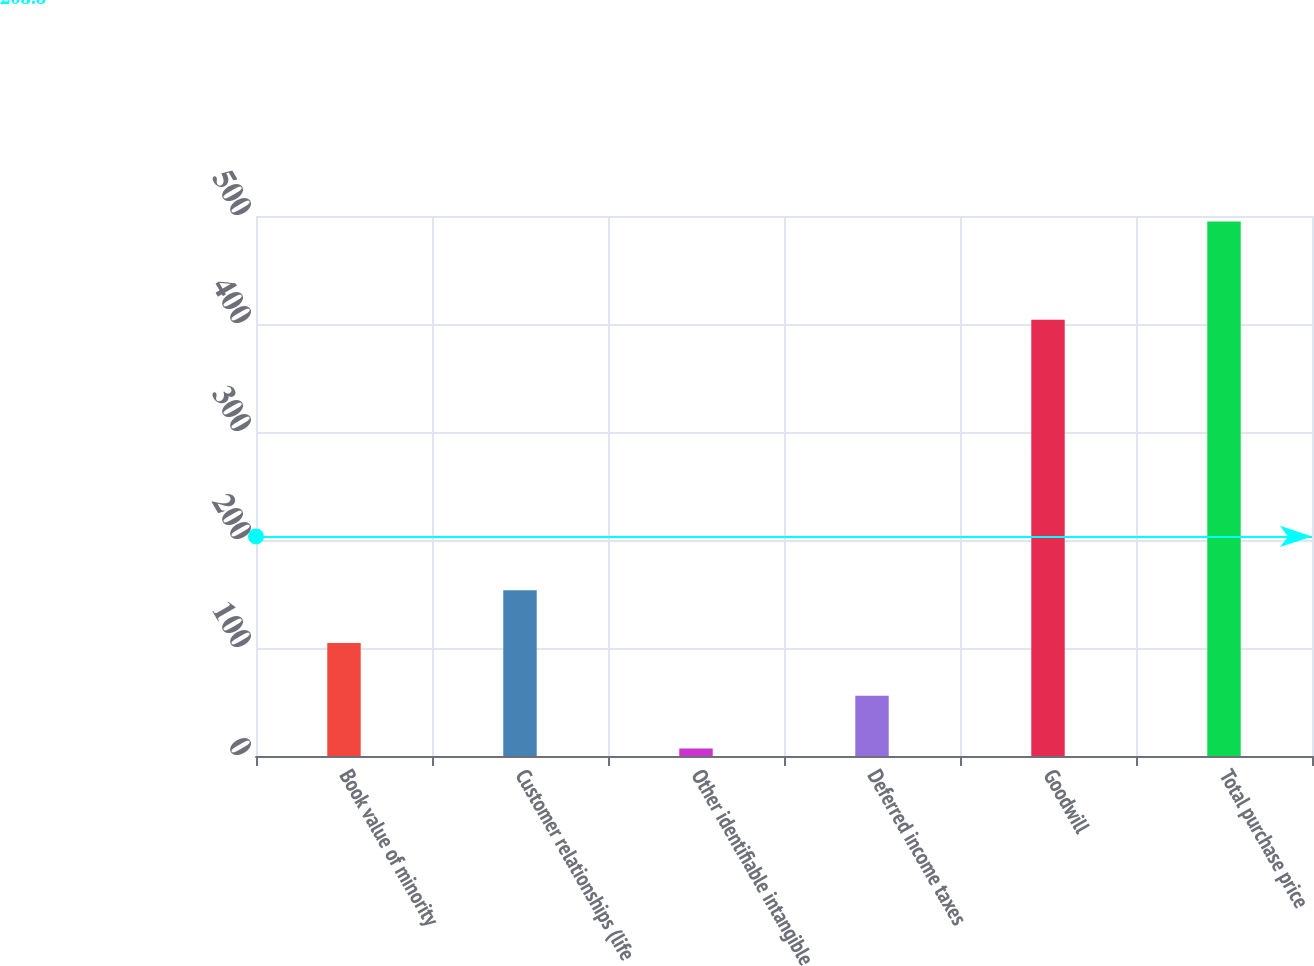Convert chart to OTSL. <chart><loc_0><loc_0><loc_500><loc_500><bar_chart><fcel>Book value of minority<fcel>Customer relationships (life<fcel>Other identifiable intangible<fcel>Deferred income taxes<fcel>Goodwill<fcel>Total purchase price<nl><fcel>104.6<fcel>153.4<fcel>7<fcel>55.8<fcel>404<fcel>495<nl></chart> 